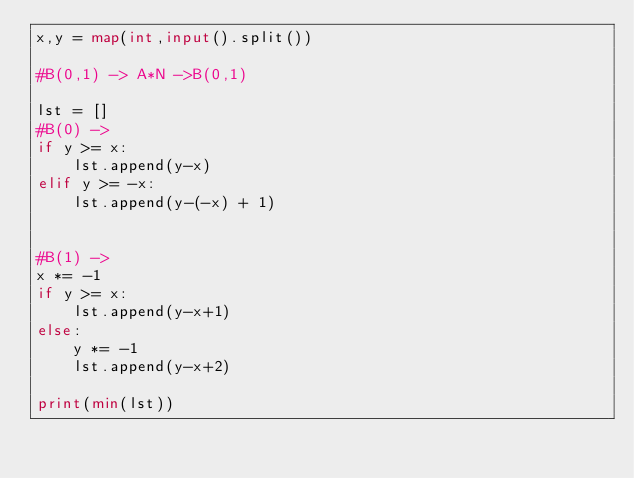<code> <loc_0><loc_0><loc_500><loc_500><_Python_>x,y = map(int,input().split())

#B(0,1) -> A*N ->B(0,1)

lst = []
#B(0) ->
if y >= x:
    lst.append(y-x)
elif y >= -x:
    lst.append(y-(-x) + 1)


#B(1) ->
x *= -1
if y >= x:
    lst.append(y-x+1)
else:
    y *= -1
    lst.append(y-x+2)

print(min(lst))</code> 